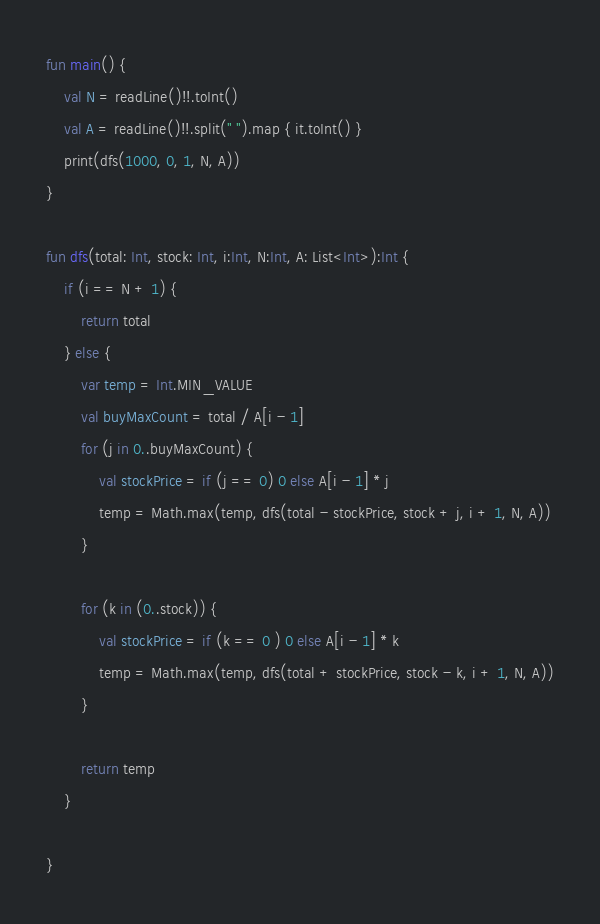<code> <loc_0><loc_0><loc_500><loc_500><_Kotlin_>fun main() {
    val N = readLine()!!.toInt()
    val A = readLine()!!.split(" ").map { it.toInt() }
    print(dfs(1000, 0, 1, N, A))
}

fun dfs(total: Int, stock: Int, i:Int, N:Int, A: List<Int>):Int {
    if (i == N + 1) {
        return total
    } else {
        var temp = Int.MIN_VALUE
        val buyMaxCount = total / A[i - 1]
        for (j in 0..buyMaxCount) {
            val stockPrice = if (j == 0) 0 else A[i - 1] * j
            temp = Math.max(temp, dfs(total - stockPrice, stock + j, i + 1, N, A))
        }

        for (k in (0..stock)) {
            val stockPrice = if (k == 0 ) 0 else A[i - 1] * k
            temp = Math.max(temp, dfs(total + stockPrice, stock - k, i + 1, N, A))
        }

        return temp
    }

}</code> 